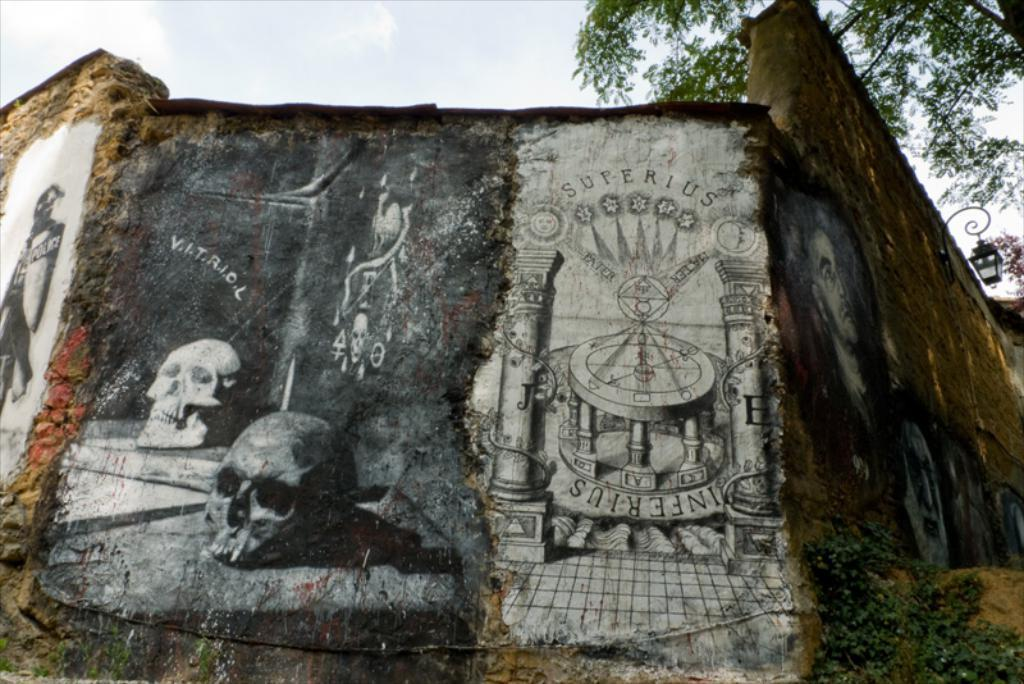What type of artwork can be seen on the wall in the image? There are paintings on the wall in the image. What natural elements are visible in the image? Trees and the sky are visible in the image. What type of lighting is present in the image? A street light is present in the image. What type of vegetation is present in the image? Creeper plants are in the image. What type of jam is being spread on the scene in the image? There is no jam or scene present in the image. What is the desire of the person in the image? There is no person present in the image, so their desires cannot be determined. 